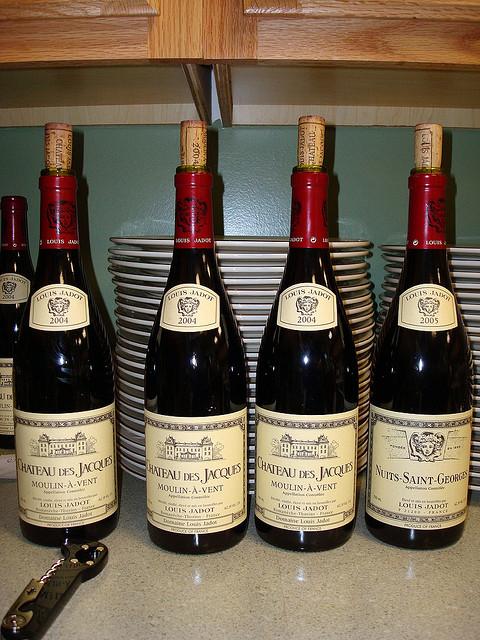Are there any wine glasses?
Short answer required. No. How many bottles are in the photo?
Quick response, please. 4. How many tall wine bottles are in the picture?
Write a very short answer. 4. How many bottles are there?
Write a very short answer. 5. Is this French wine?
Concise answer only. Yes. 